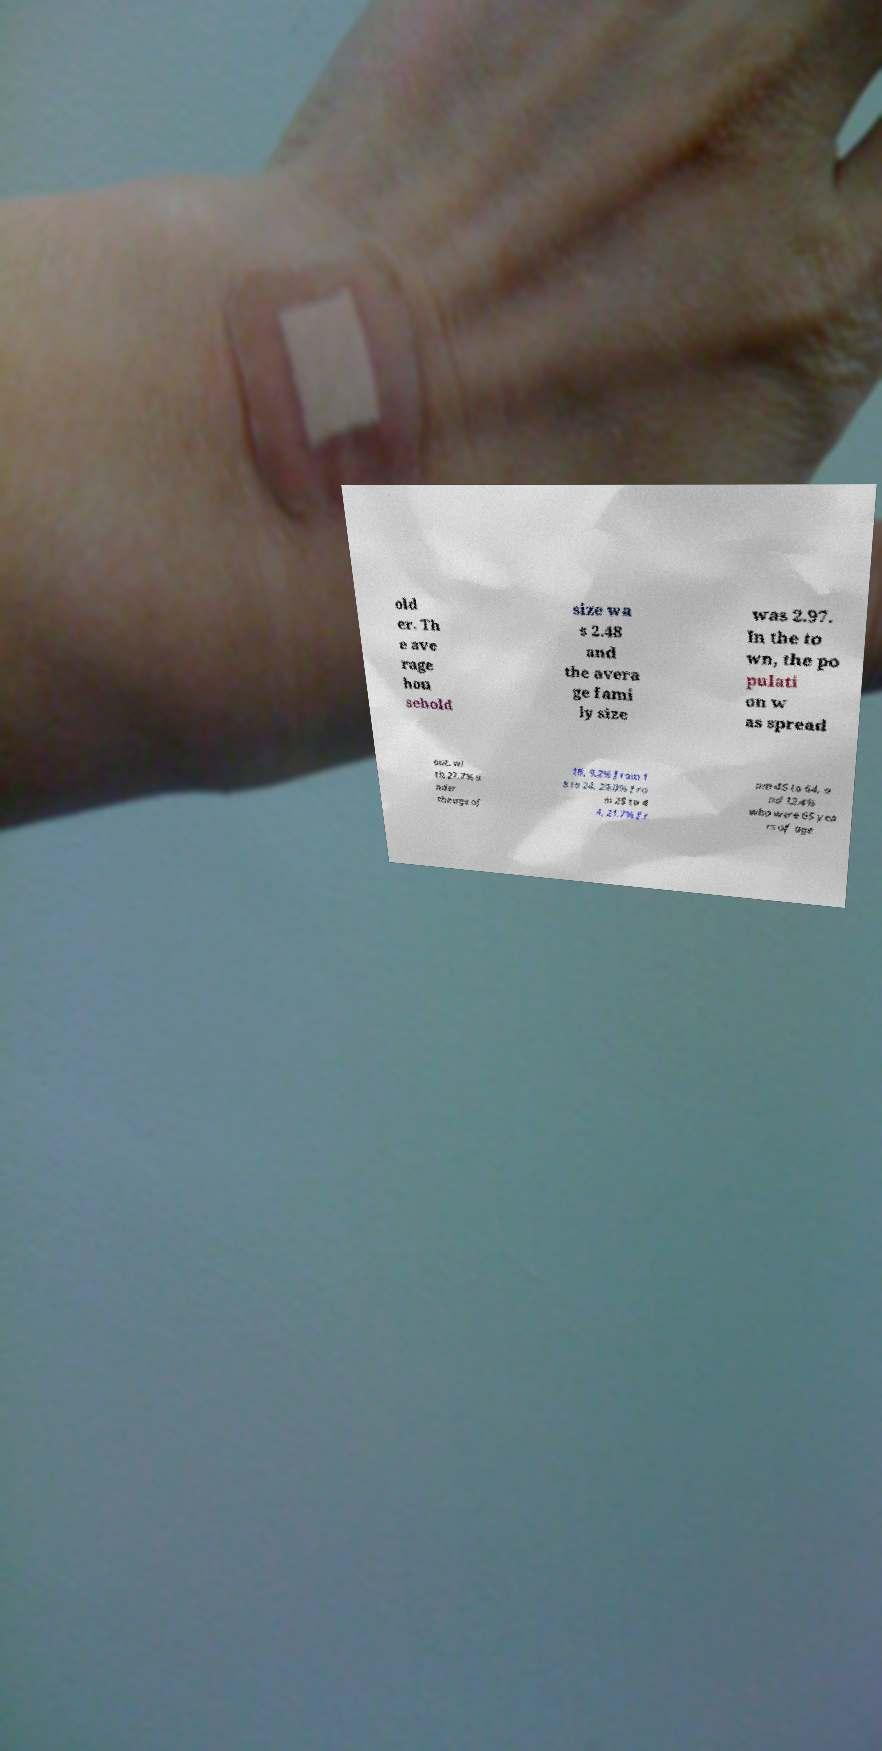I need the written content from this picture converted into text. Can you do that? old er. Th e ave rage hou sehold size wa s 2.48 and the avera ge fami ly size was 2.97. In the to wn, the po pulati on w as spread out, wi th 27.7% u nder the age of 18, 9.2% from 1 8 to 24, 29.0% fro m 25 to 4 4, 21.7% fr om 45 to 64, a nd 12.4% who were 65 yea rs of age 